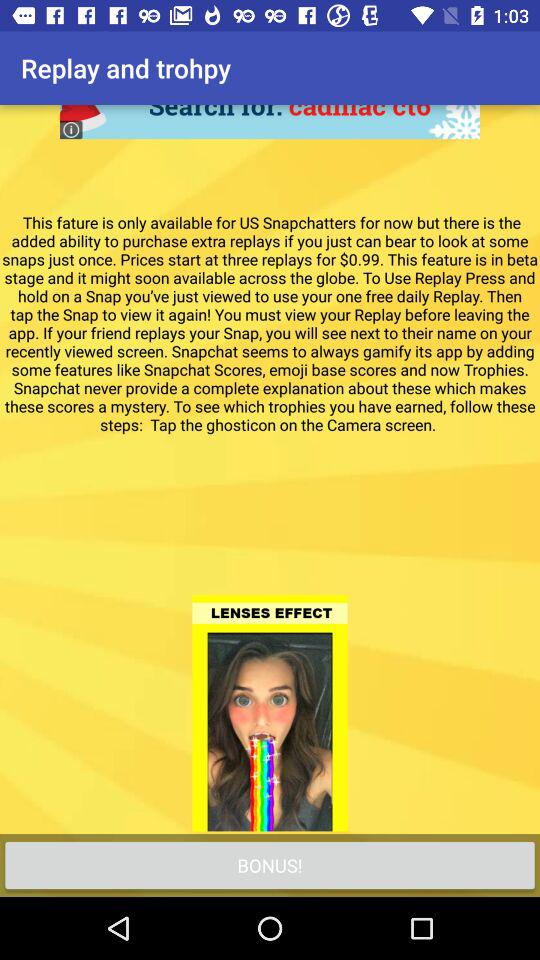What is the price for three replays of snaps? The price is $0.99. 